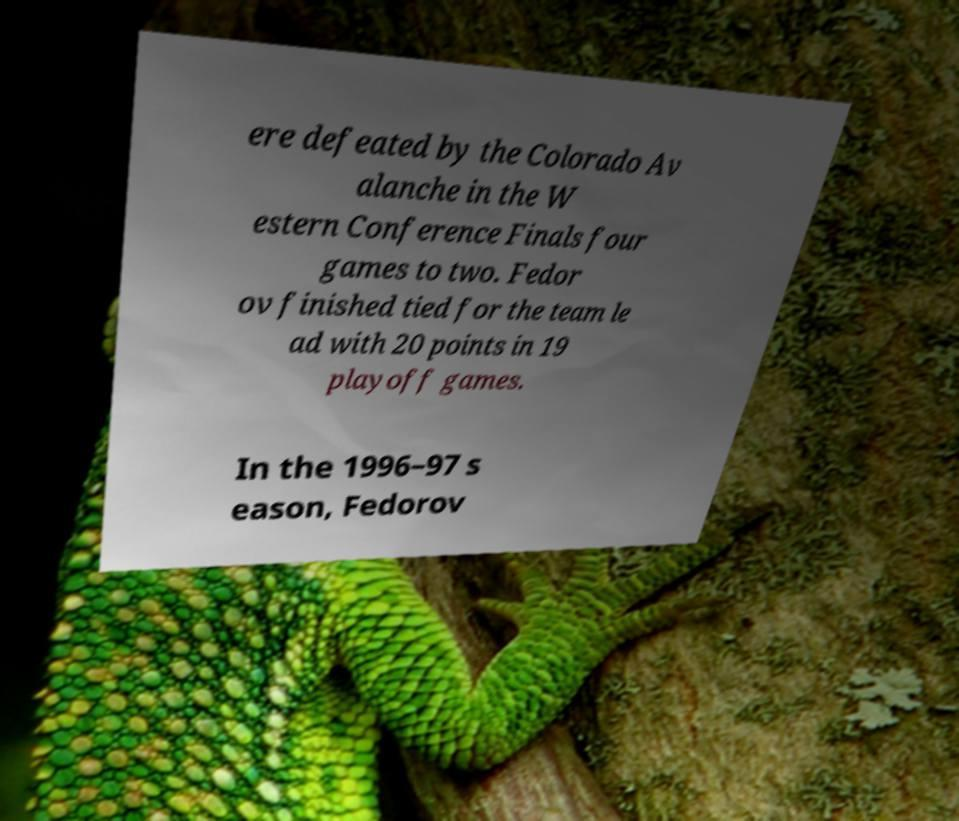Please identify and transcribe the text found in this image. ere defeated by the Colorado Av alanche in the W estern Conference Finals four games to two. Fedor ov finished tied for the team le ad with 20 points in 19 playoff games. In the 1996–97 s eason, Fedorov 